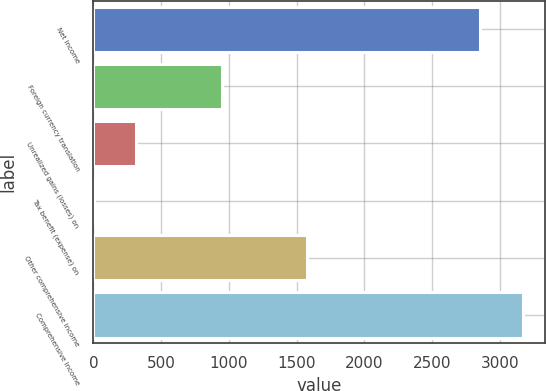Convert chart. <chart><loc_0><loc_0><loc_500><loc_500><bar_chart><fcel>Net income<fcel>Foreign currency translation<fcel>Unrealized gains (losses) on<fcel>Tax benefit (expense) on<fcel>Other comprehensive income<fcel>Comprehensive income<nl><fcel>2856<fcel>948.2<fcel>317.4<fcel>2<fcel>1579<fcel>3171.4<nl></chart> 